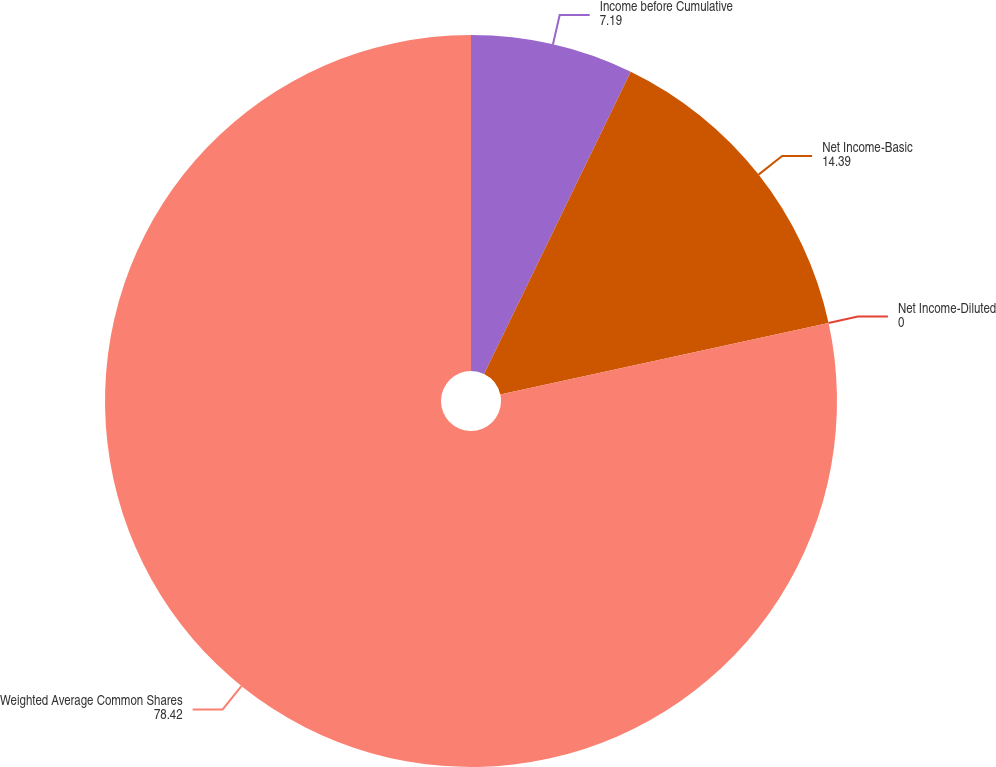Convert chart. <chart><loc_0><loc_0><loc_500><loc_500><pie_chart><fcel>Income before Cumulative<fcel>Net Income-Basic<fcel>Net Income-Diluted<fcel>Weighted Average Common Shares<nl><fcel>7.19%<fcel>14.39%<fcel>0.0%<fcel>78.42%<nl></chart> 